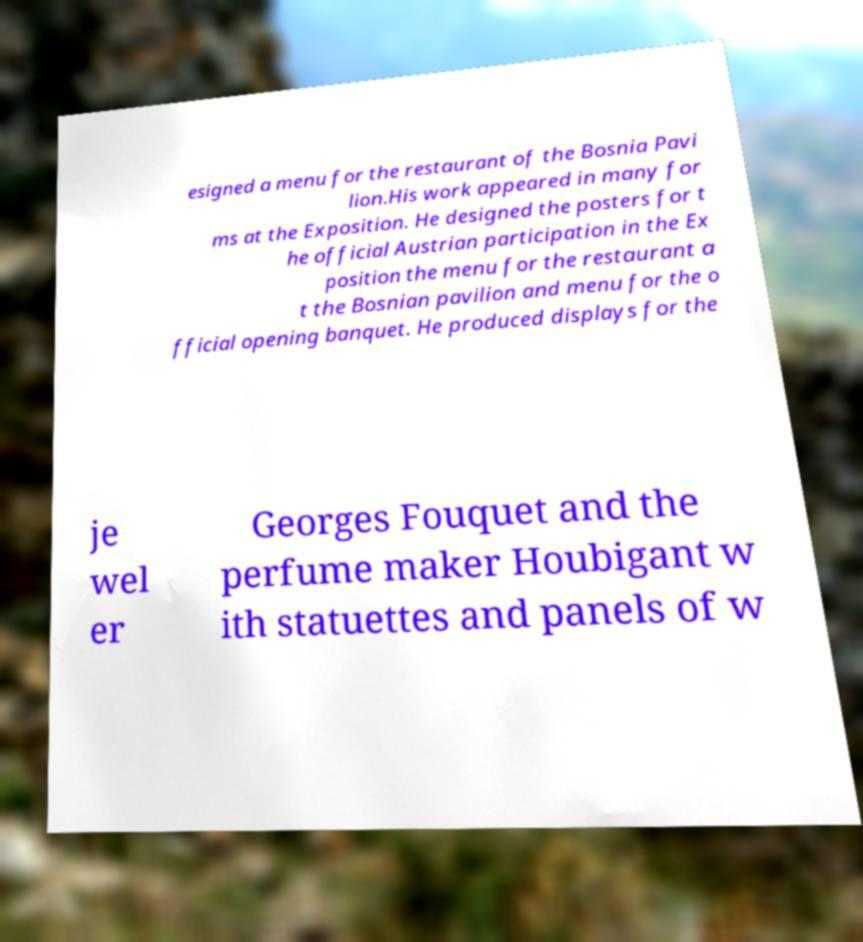Can you read and provide the text displayed in the image?This photo seems to have some interesting text. Can you extract and type it out for me? esigned a menu for the restaurant of the Bosnia Pavi lion.His work appeared in many for ms at the Exposition. He designed the posters for t he official Austrian participation in the Ex position the menu for the restaurant a t the Bosnian pavilion and menu for the o fficial opening banquet. He produced displays for the je wel er Georges Fouquet and the perfume maker Houbigant w ith statuettes and panels of w 